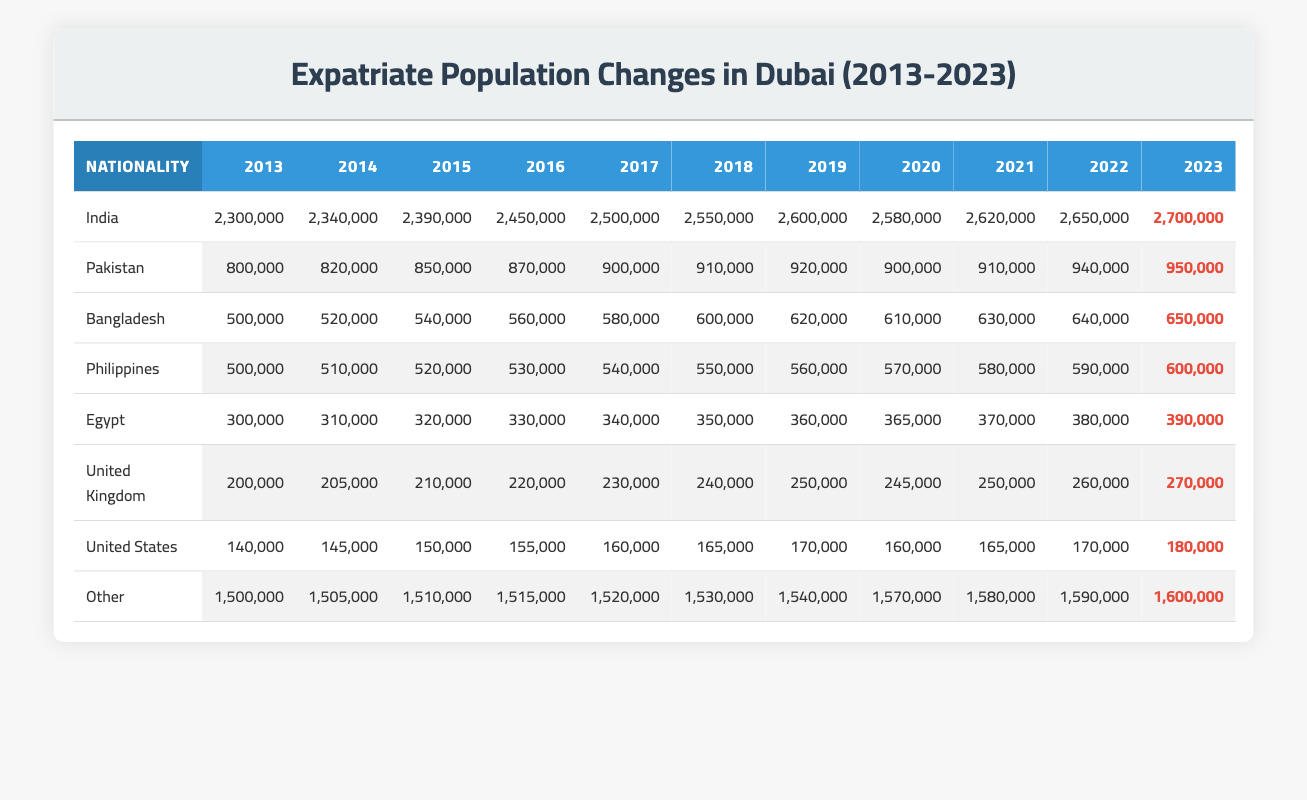What was the expatriate population from India in 2020? The table shows that the population from India in 2020 is listed under the column for that year, which is 2,580,000.
Answer: 2,580,000 What is the total expatriate population from Pakistan and Bangladesh in 2023? From the table, the population from Pakistan in 2023 is 950,000 and from Bangladesh is 650,000. Adding these together gives 950,000 + 650,000 = 1,600,000.
Answer: 1,600,000 Is the expatriate population from Egypt in 2022 greater than that of the United Kingdom in the same year? The population from Egypt in 2022 is 380,000, while that from the United Kingdom is 260,000. Since 380,000 is greater than 260,000, the statement is true.
Answer: Yes Which nationality had the highest growth from 2013 to 2023? Looking at the data in the table, the population of Indians increased from 2,300,000 in 2013 to 2,700,000 in 2023, resulting in a growth of 400,000. Other nationalities were analyzed similarly: Pakistan (+150,000), Bangladesh (+150,000), and others. The highest growth was from India.
Answer: India What was the average expatriate population from the United States from 2013 to 2023? The table provides the population of the United States for each year: 140,000, 145,000, 150,000, 155,000, 160,000, 165,000, 170,000, 160,000, 165,000, 170,000, and 180,000. Summing these gives 1,645,000, and since there are 11 data points, the average is 1,645,000 / 11 ≈ 149545.45, which gives a rounded average of 149,545.
Answer: 149,545 Did the population of expatriates from the Philippines exceed that of Egypt in any year? Comparing the populations year by year, the population from the Philippines starts at 500,000 in 2013 and reaches 600,000 in 2023. Meanwhile, Egypt's population at the same years starts at 300,000 and ends at 390,000. In all years analyzed, the Philippines population exceeded Egypt's population from 2019 onwards.
Answer: Yes What was the change in the population of expatriates from the United Kingdom from 2013 to 2023? The population of the United Kingdom in 2013 was 200,000 and increased to 270,000 in 2023. The change is calculated as 270,000 - 200,000 = 70,000.
Answer: 70,000 Was there a decline in the population of expatriates from any nationality during the decade? In examining the table, the only year with a decline is for India from 2019 to 2020, where it decreased from 2,600,000 to 2,580,000. Therefore, a decline is noted for India.
Answer: Yes How do the expatriate populations from "Other" nationalities trend over the years? The data shows that the population from "Other" nationalities consistently increased each year. The starting value is 1,500,000 in 2013 and it grows to 1,600,000 in 2023, confirming a positive trend with no declines.
Answer: Increasing trend Calculate the median expatriate population from Bangladesh over the years. The populations for Bangladesh are: 500,000, 520,000, 540,000, 560,000, 580,000, 600,000, 620,000, 610,000, 630,000, 640,000, and 650,000. With 11 data points, the median is the 6th value, which is 600,000.
Answer: 600,000 